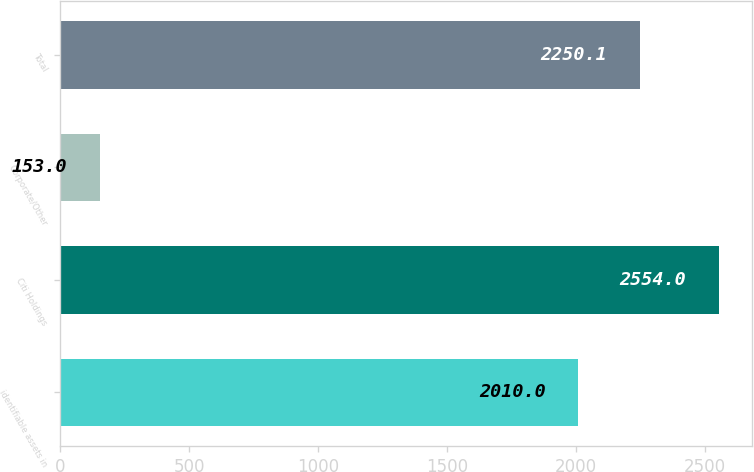Convert chart. <chart><loc_0><loc_0><loc_500><loc_500><bar_chart><fcel>identifiable assets in<fcel>Citi Holdings<fcel>Corporate/Other<fcel>Total<nl><fcel>2010<fcel>2554<fcel>153<fcel>2250.1<nl></chart> 